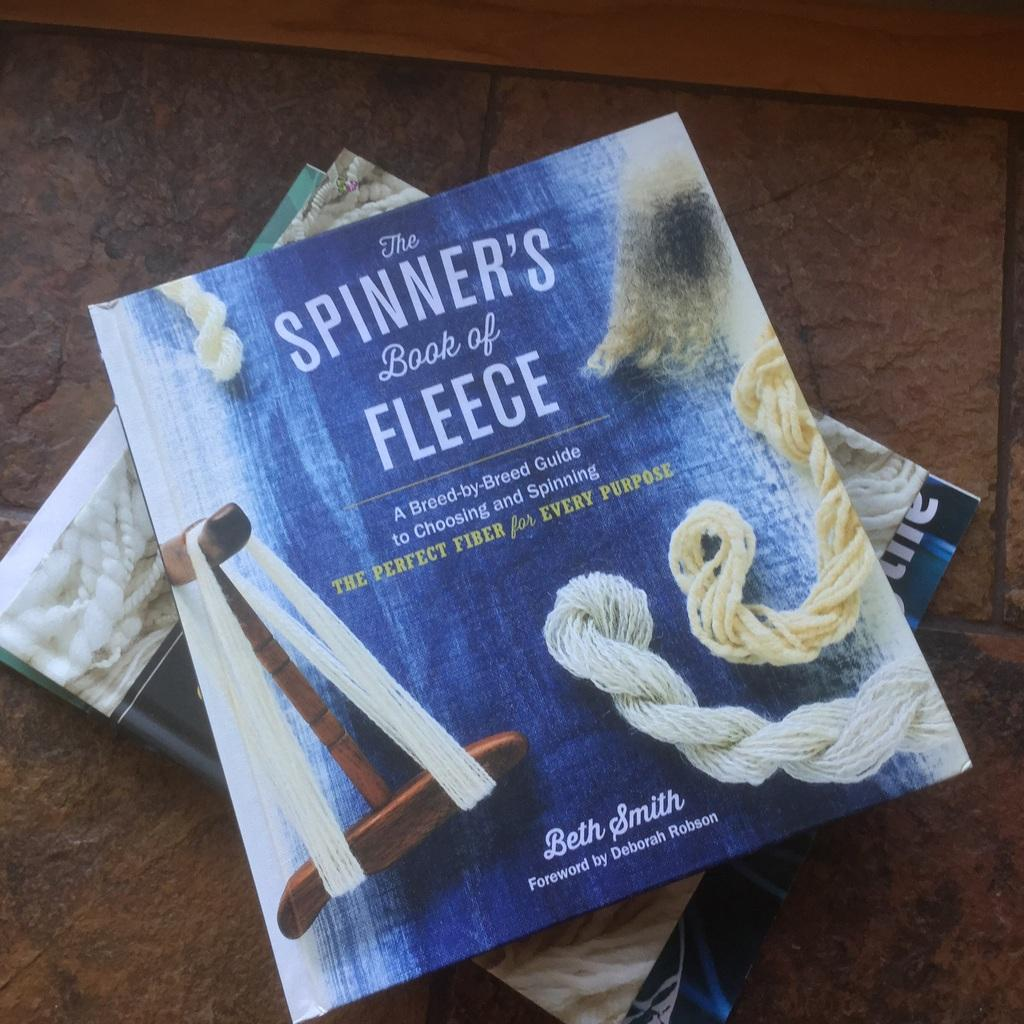<image>
Offer a succinct explanation of the picture presented. A text book titled The spinners book of fleece. 